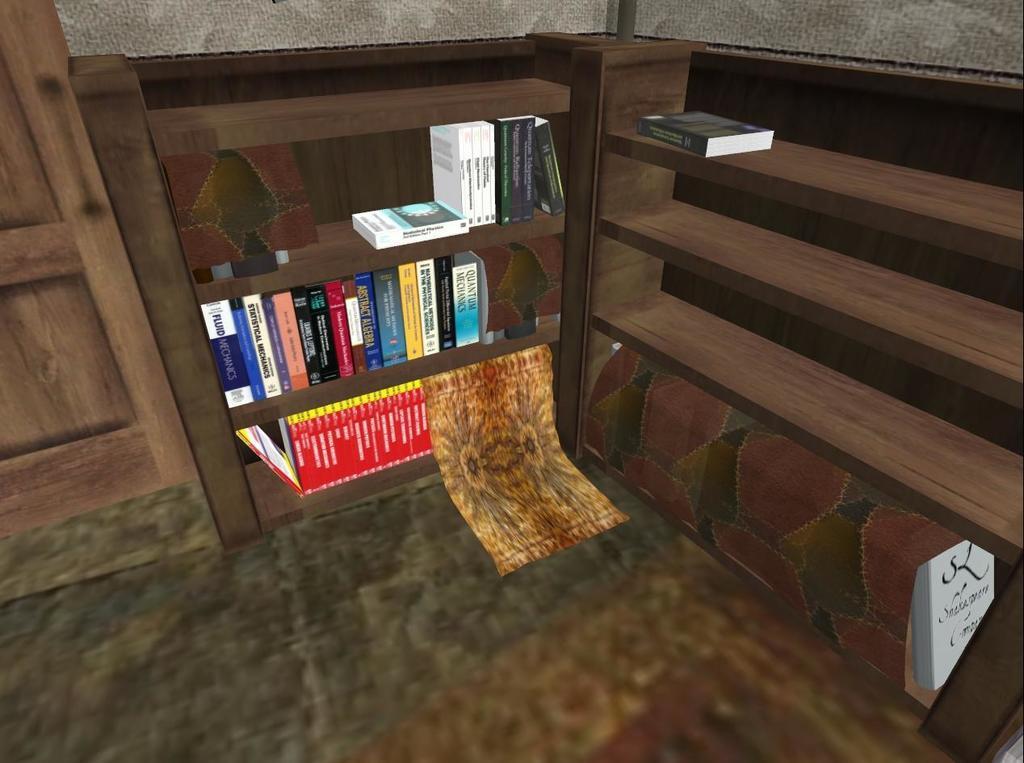Describe this image in one or two sentences. This is the anime image of a room with books in a wooden rack and a door on the left side. 